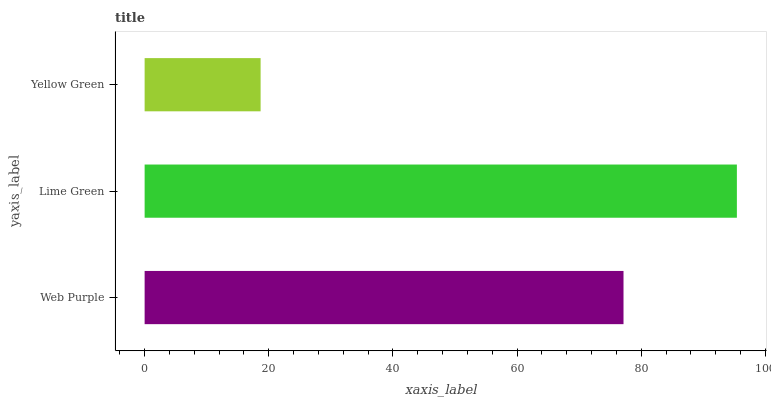Is Yellow Green the minimum?
Answer yes or no. Yes. Is Lime Green the maximum?
Answer yes or no. Yes. Is Lime Green the minimum?
Answer yes or no. No. Is Yellow Green the maximum?
Answer yes or no. No. Is Lime Green greater than Yellow Green?
Answer yes or no. Yes. Is Yellow Green less than Lime Green?
Answer yes or no. Yes. Is Yellow Green greater than Lime Green?
Answer yes or no. No. Is Lime Green less than Yellow Green?
Answer yes or no. No. Is Web Purple the high median?
Answer yes or no. Yes. Is Web Purple the low median?
Answer yes or no. Yes. Is Yellow Green the high median?
Answer yes or no. No. Is Yellow Green the low median?
Answer yes or no. No. 